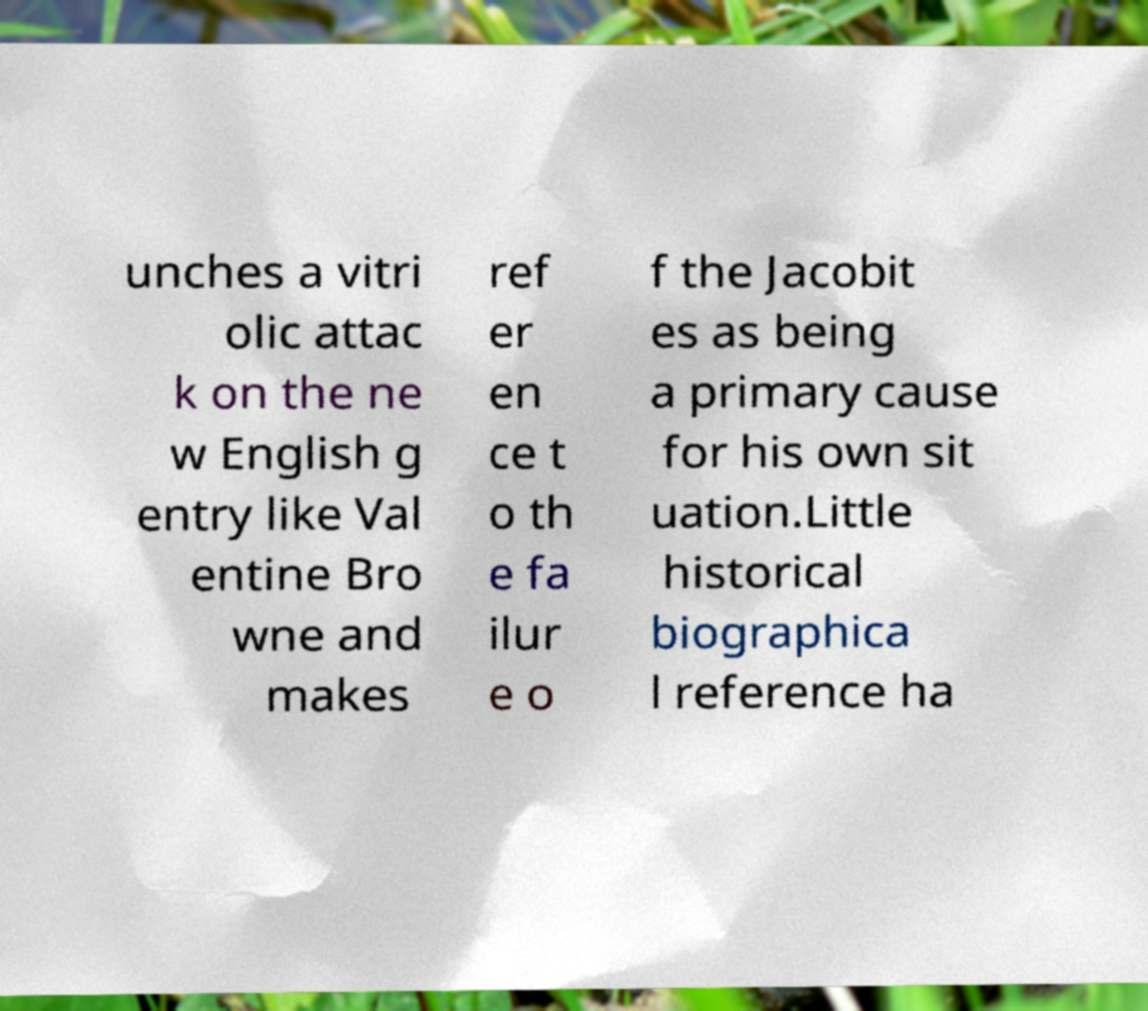Could you extract and type out the text from this image? unches a vitri olic attac k on the ne w English g entry like Val entine Bro wne and makes ref er en ce t o th e fa ilur e o f the Jacobit es as being a primary cause for his own sit uation.Little historical biographica l reference ha 